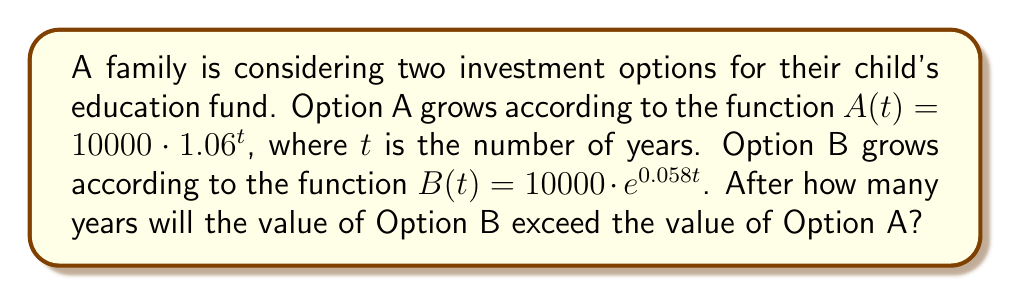Teach me how to tackle this problem. To solve this problem, we need to find the point where the two functions intersect. Let's follow these steps:

1) Set up the equation:
   $10000 \cdot 1.06^t = 10000 \cdot e^{0.058t}$

2) The $10000$ cancels out on both sides:
   $1.06^t = e^{0.058t}$

3) Take the natural logarithm of both sides:
   $\ln(1.06^t) = \ln(e^{0.058t})$

4) Use the logarithm property $\ln(a^b) = b\ln(a)$:
   $t \cdot \ln(1.06) = 0.058t$

5) Factor out $t$:
   $t(\ln(1.06) - 0.058) = 0$

6) Solve for $t$:
   $t = 0$ or $\ln(1.06) - 0.058 = 0$

7) Calculate $\ln(1.06)$:
   $\ln(1.06) \approx 0.05827$

8) Since $0.05827 > 0.058$, Option B will exceed Option A after $t = 0$.

9) To find when Option B first exceeds Option A, we need to find the smallest integer $t$ where $B(t) > A(t)$:

   For $t = 1$:
   $A(1) = 10000 \cdot 1.06^1 = 10600$
   $B(1) = 10000 \cdot e^{0.058 \cdot 1} \approx 10597$

   For $t = 2$:
   $A(2) = 10000 \cdot 1.06^2 = 11236$
   $B(2) = 10000 \cdot e^{0.058 \cdot 2} \approx 11219$

   For $t = 3$:
   $A(3) = 10000 \cdot 1.06^3 = 11910$
   $B(3) = 10000 \cdot e^{0.058 \cdot 3} \approx 11869$

   For $t = 4$:
   $A(4) = 10000 \cdot 1.06^4 = 12625$
   $B(4) = 10000 \cdot e^{0.058 \cdot 4} \approx 12548$

   For $t = 5$:
   $A(5) = 10000 \cdot 1.06^5 = 13382$
   $B(5) = 10000 \cdot e^{0.058 \cdot 5} \approx 13257$

   For $t = 6$:
   $A(6) = 10000 \cdot 1.06^6 = 14185$
   $B(6) = 10000 \cdot e^{0.058 \cdot 6} \approx 13998$

   For $t = 7$:
   $A(7) = 10000 \cdot 1.06^7 = 15036$
   $B(7) = 10000 \cdot e^{0.058 \cdot 7} \approx 14773$

   For $t = 8$:
   $A(8) = 10000 \cdot 1.06^8 = 15938$
   $B(8) = 10000 \cdot e^{0.058 \cdot 8} \approx 15583$

   For $t = 9$:
   $A(9) = 10000 \cdot 1.06^9 = 16895$
   $B(9) = 10000 \cdot e^{0.058 \cdot 9} \approx 16431$

   For $t = 10$:
   $A(10) = 10000 \cdot 1.06^{10} = 17908$
   $B(10) = 10000 \cdot e^{0.058 \cdot 10} \approx 17319$

   For $t = 11$:
   $A(11) = 10000 \cdot 1.06^{11} = 18983$
   $B(11) = 10000 \cdot e^{0.058 \cdot 11} \approx 18249$

   For $t = 12$:
   $A(12) = 10000 \cdot 1.06^{12} = 20122$
   $B(12) = 10000 \cdot e^{0.058 \cdot 12} \approx 19223$

   For $t = 13$:
   $A(13) = 10000 \cdot 1.06^{13} = 21329$
   $B(13) = 10000 \cdot e^{0.058 \cdot 13} \approx 20244$

   For $t = 14$:
   $A(14) = 10000 \cdot 1.06^{14} = 22609$
   $B(14) = 10000 \cdot e^{0.058 \cdot 14} \approx 21314$

   For $t = 15$:
   $A(15) = 10000 \cdot 1.06^{15} = 23966$
   $B(15) = 10000 \cdot e^{0.058 \cdot 15} \approx 22436$

Therefore, Option B will first exceed Option A after 15 years.
Answer: 15 years 